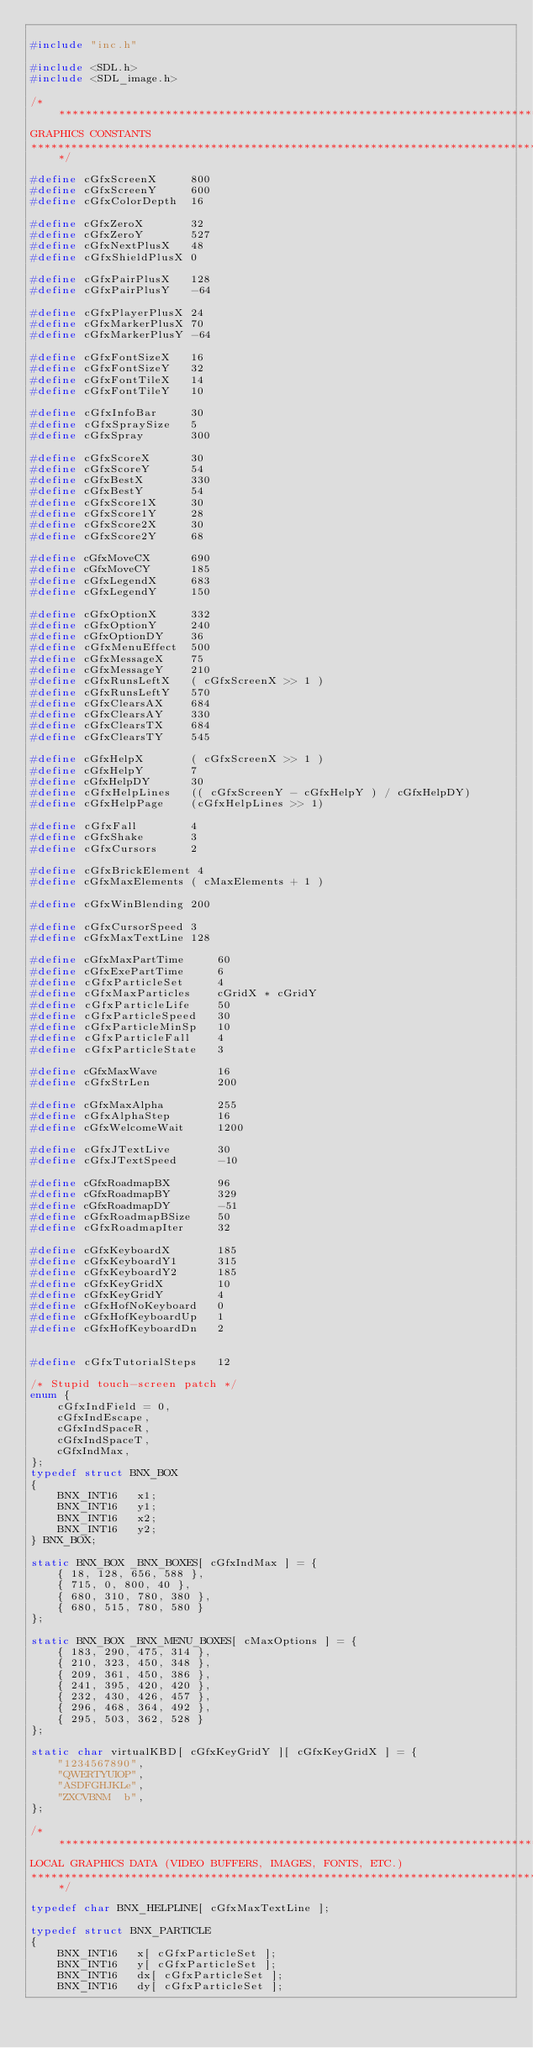<code> <loc_0><loc_0><loc_500><loc_500><_C_>
#include "inc.h"

#include <SDL.h>
#include <SDL_image.h>

/******************************************************************************
GRAPHICS CONSTANTS
******************************************************************************/

#define cGfxScreenX		800
#define cGfxScreenY		600
#define cGfxColorDepth	16

#define cGfxZeroX		32
#define cGfxZeroY		527
#define cGfxNextPlusX	48
#define cGfxShieldPlusX	0

#define cGfxPairPlusX	128
#define cGfxPairPlusY	-64

#define cGfxPlayerPlusX	24
#define cGfxMarkerPlusX	70
#define cGfxMarkerPlusY	-64

#define cGfxFontSizeX	16
#define cGfxFontSizeY	32
#define cGfxFontTileX	14
#define cGfxFontTileY	10

#define cGfxInfoBar		30
#define cGfxSpraySize	5
#define cGfxSpray		300

#define cGfxScoreX		30
#define cGfxScoreY		54
#define cGfxBestX		330
#define cGfxBestY		54
#define cGfxScore1X		30
#define cGfxScore1Y		28
#define cGfxScore2X		30
#define cGfxScore2Y		68

#define cGfxMoveCX		690
#define cGfxMoveCY		185
#define cGfxLegendX		683
#define cGfxLegendY		150

#define cGfxOptionX		332
#define cGfxOptionY		240
#define cGfxOptionDY	36
#define cGfxMenuEffect	500
#define cGfxMessageX	75
#define cGfxMessageY	210
#define cGfxRunsLeftX	( cGfxScreenX >> 1 )
#define cGfxRunsLeftY	570
#define cGfxClearsAX	684
#define cGfxClearsAY	330
#define cGfxClearsTX	684
#define cGfxClearsTY	545

#define cGfxHelpX		( cGfxScreenX >> 1 )
#define cGfxHelpY		7
#define cGfxHelpDY		30
#define cGfxHelpLines	(( cGfxScreenY - cGfxHelpY ) / cGfxHelpDY)
#define cGfxHelpPage	(cGfxHelpLines >> 1)

#define cGfxFall		4
#define cGfxShake		3
#define cGfxCursors		2

#define cGfxBrickElement 4
#define cGfxMaxElements ( cMaxElements + 1 )

#define cGfxWinBlending	200

#define cGfxCursorSpeed	3
#define cGfxMaxTextLine	128

#define cGfxMaxPartTime		60
#define cGfxExePartTime		6
#define cGfxParticleSet		4
#define cGfxMaxParticles	cGridX * cGridY
#define cGfxParticleLife	50
#define cGfxParticleSpeed	30
#define cGfxParticleMinSp	10
#define cGfxParticleFall	4
#define cGfxParticleState	3

#define cGfxMaxWave			16
#define cGfxStrLen			200

#define cGfxMaxAlpha		255
#define cGfxAlphaStep		16
#define cGfxWelcomeWait		1200

#define cGfxJTextLive		30
#define cGfxJTextSpeed		-10

#define cGfxRoadmapBX		96
#define cGfxRoadmapBY		329
#define cGfxRoadmapDY		-51
#define cGfxRoadmapBSize	50
#define cGfxRoadmapIter		32

#define cGfxKeyboardX		185
#define cGfxKeyboardY1		315
#define cGfxKeyboardY2		185
#define cGfxKeyGridX		10
#define cGfxKeyGridY		4
#define cGfxHofNoKeyboard	0
#define cGfxHofKeyboardUp	1
#define cGfxHofKeyboardDn	2


#define cGfxTutorialSteps	12

/* Stupid touch-screen patch */
enum {
	cGfxIndField = 0,
	cGfxIndEscape,
	cGfxIndSpaceR,
	cGfxIndSpaceT,
	cGfxIndMax,
};
typedef struct BNX_BOX
{
	BNX_INT16	x1;
	BNX_INT16	y1;
	BNX_INT16	x2;
	BNX_INT16	y2;
} BNX_BOX;

static BNX_BOX _BNX_BOXES[ cGfxIndMax ] = {
	{ 18, 128, 656, 588 },
	{ 715, 0, 800, 40 },
	{ 680, 310, 780, 380 },
	{ 680, 515, 780, 580 }
};

static BNX_BOX _BNX_MENU_BOXES[ cMaxOptions ] = {
	{ 183, 290, 475, 314 },
	{ 210, 323, 450, 348 },
	{ 209, 361, 450, 386 },
	{ 241, 395, 420, 420 },
	{ 232, 430, 426, 457 },
	{ 296, 468, 364, 492 },
	{ 295, 503, 362, 528 }
};

static char virtualKBD[ cGfxKeyGridY ][ cGfxKeyGridX ] = {
	"1234567890",
	"QWERTYUIOP",
	"ASDFGHJKLe",
	"ZXCVBNM  b",
};

/******************************************************************************
LOCAL GRAPHICS DATA (VIDEO BUFFERS, IMAGES, FONTS, ETC.)
******************************************************************************/

typedef char BNX_HELPLINE[ cGfxMaxTextLine ];

typedef struct BNX_PARTICLE
{
	BNX_INT16	x[ cGfxParticleSet ];
	BNX_INT16	y[ cGfxParticleSet ];
	BNX_INT16	dx[ cGfxParticleSet ];
	BNX_INT16	dy[ cGfxParticleSet ];</code> 